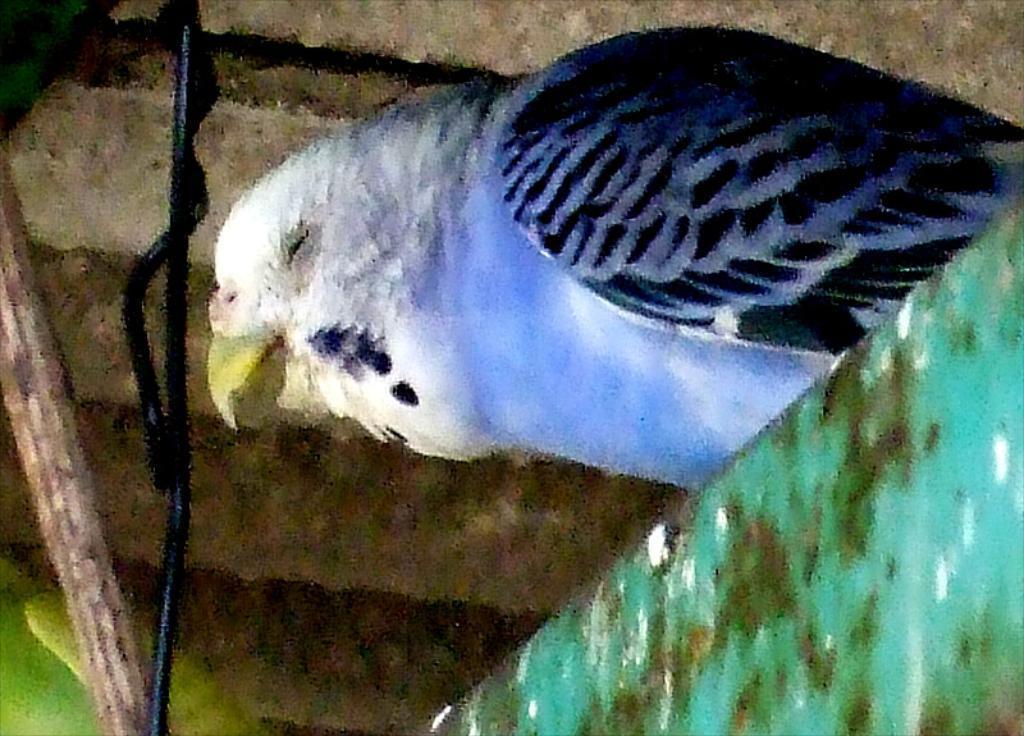In one or two sentences, can you explain what this image depicts? In this image, I can see a bird on an object. This picture looks slightly blurred. On the left side of the image, It looks like a branch. 